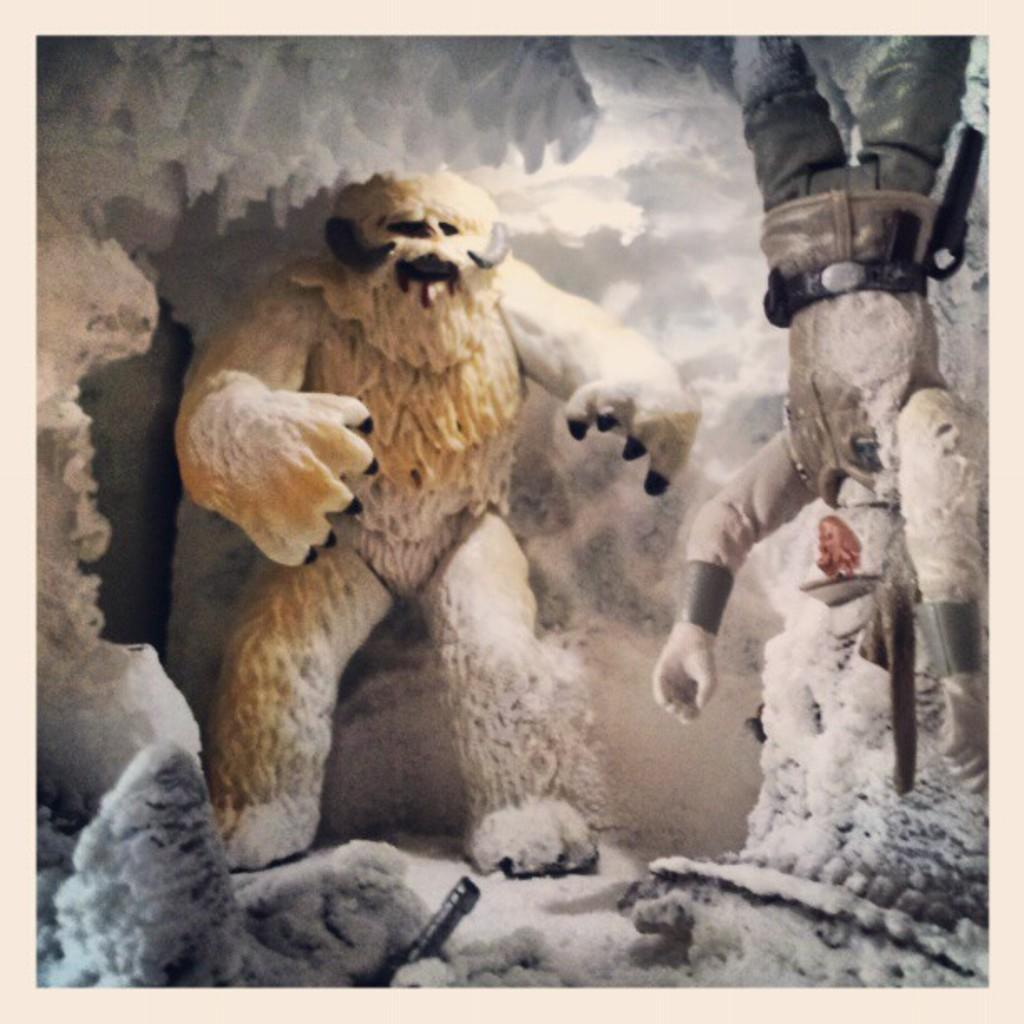What type of sculpture can be seen in the image? There is a white-colored sculpture of a yeti in the image. Are there any other sculptures present in the image? Yes, there is a sculpture of a person in the image. What material is visible in the image? Ice is visible in the image. What type of act is the yeti performing in the image? There is no act being performed by the yeti sculpture in the image; it is a static sculpture. Can you see any cracks in the ice in the image? The provided facts do not mention any cracks in the ice, so we cannot determine if any are present. Is there any exchange happening between the two sculptures in the image? There is no exchange happening between the two sculptures in the image; they are both static sculptures. 